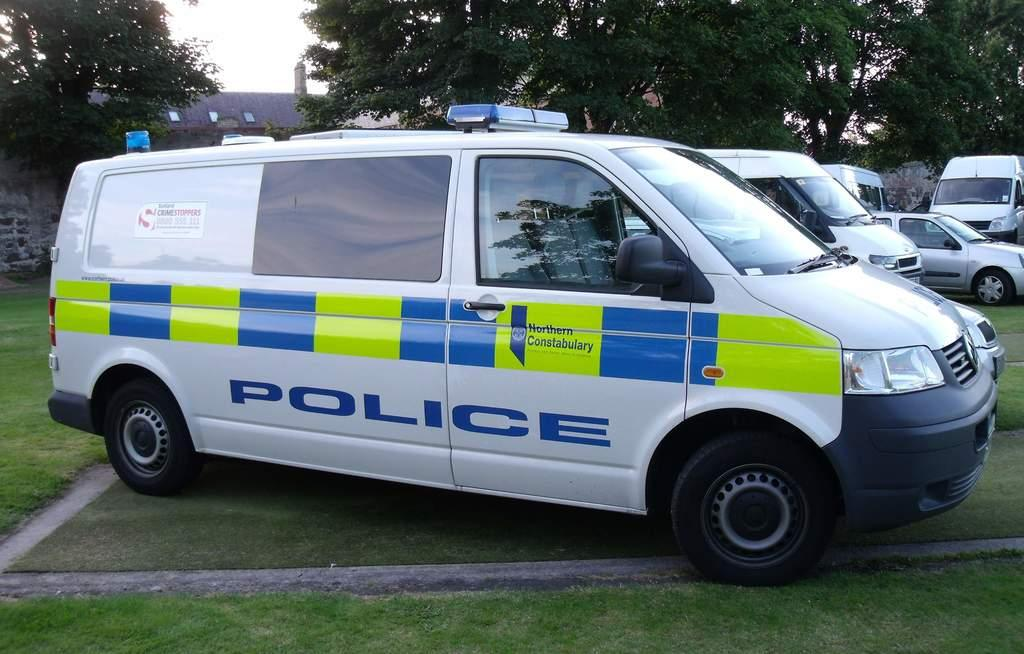<image>
Create a compact narrative representing the image presented. a car that says police on the side 